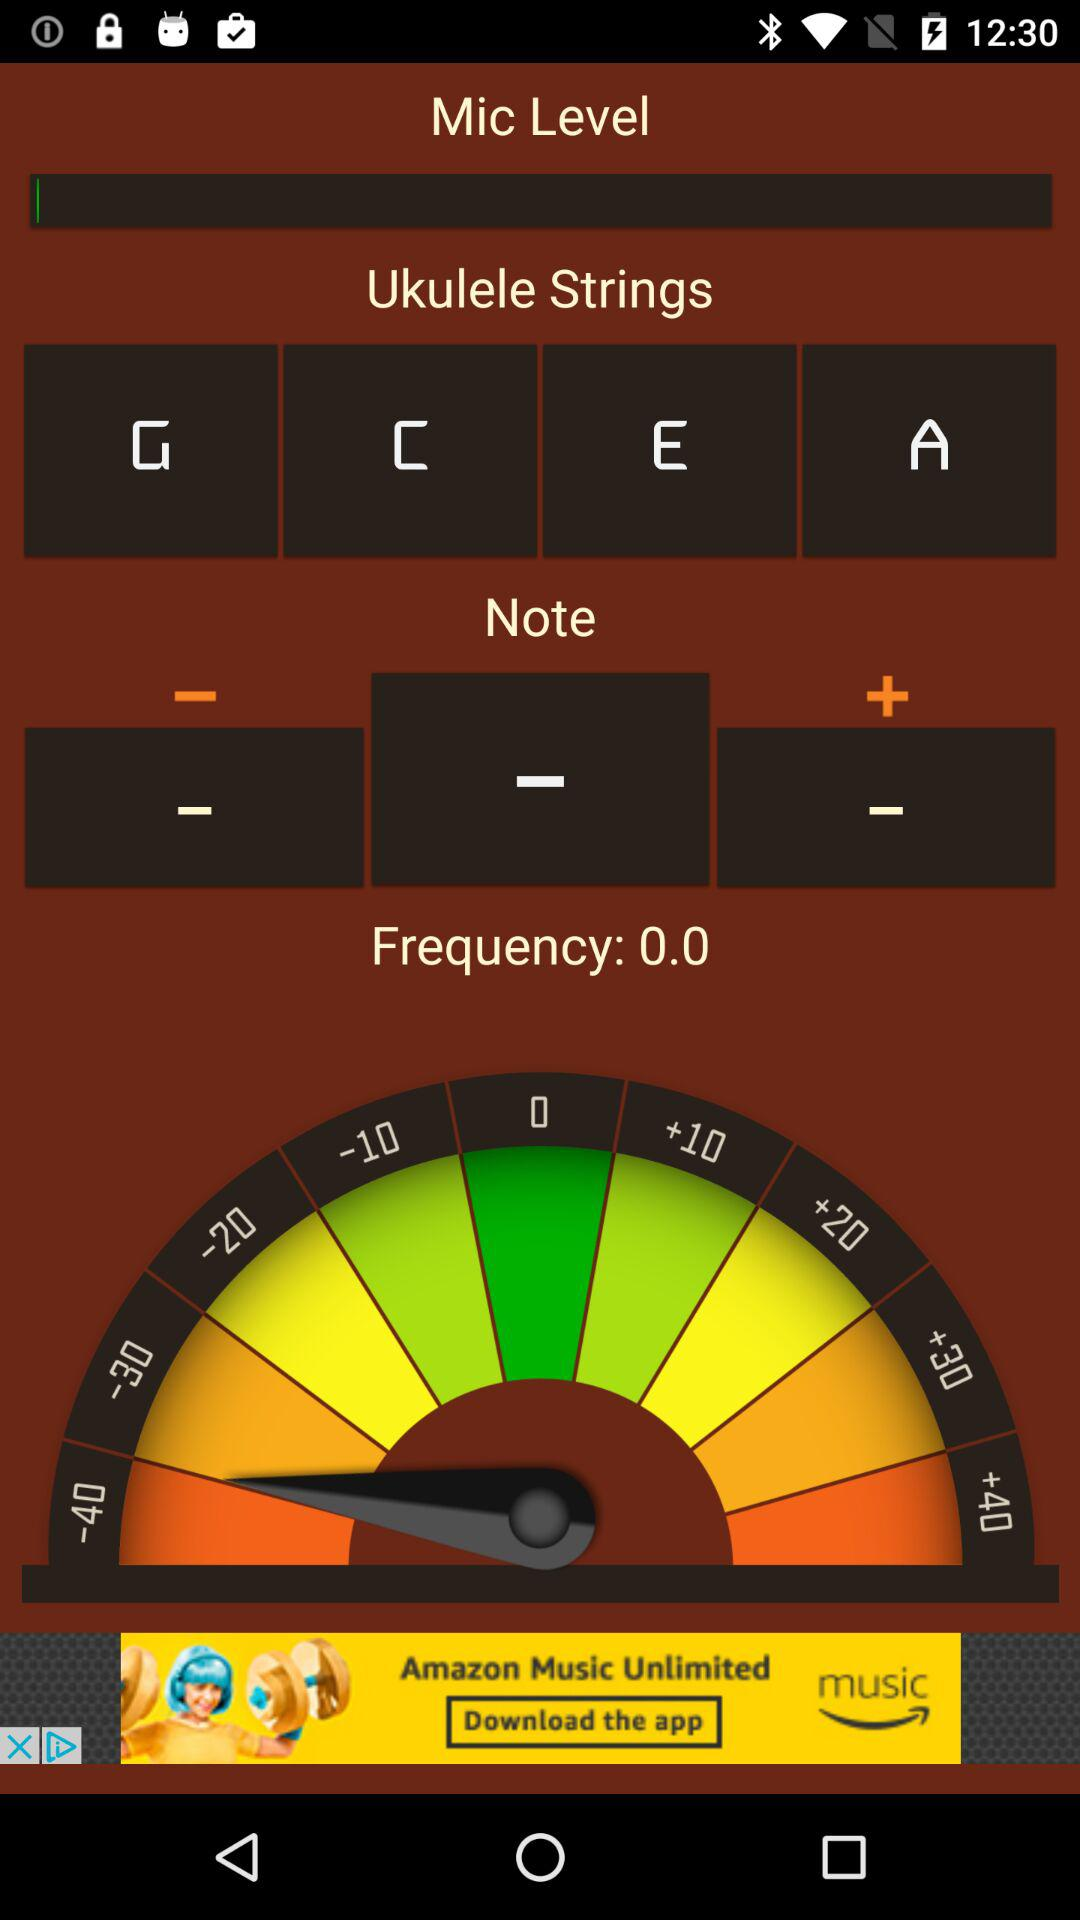What is the frequency? The frequency is 0. 